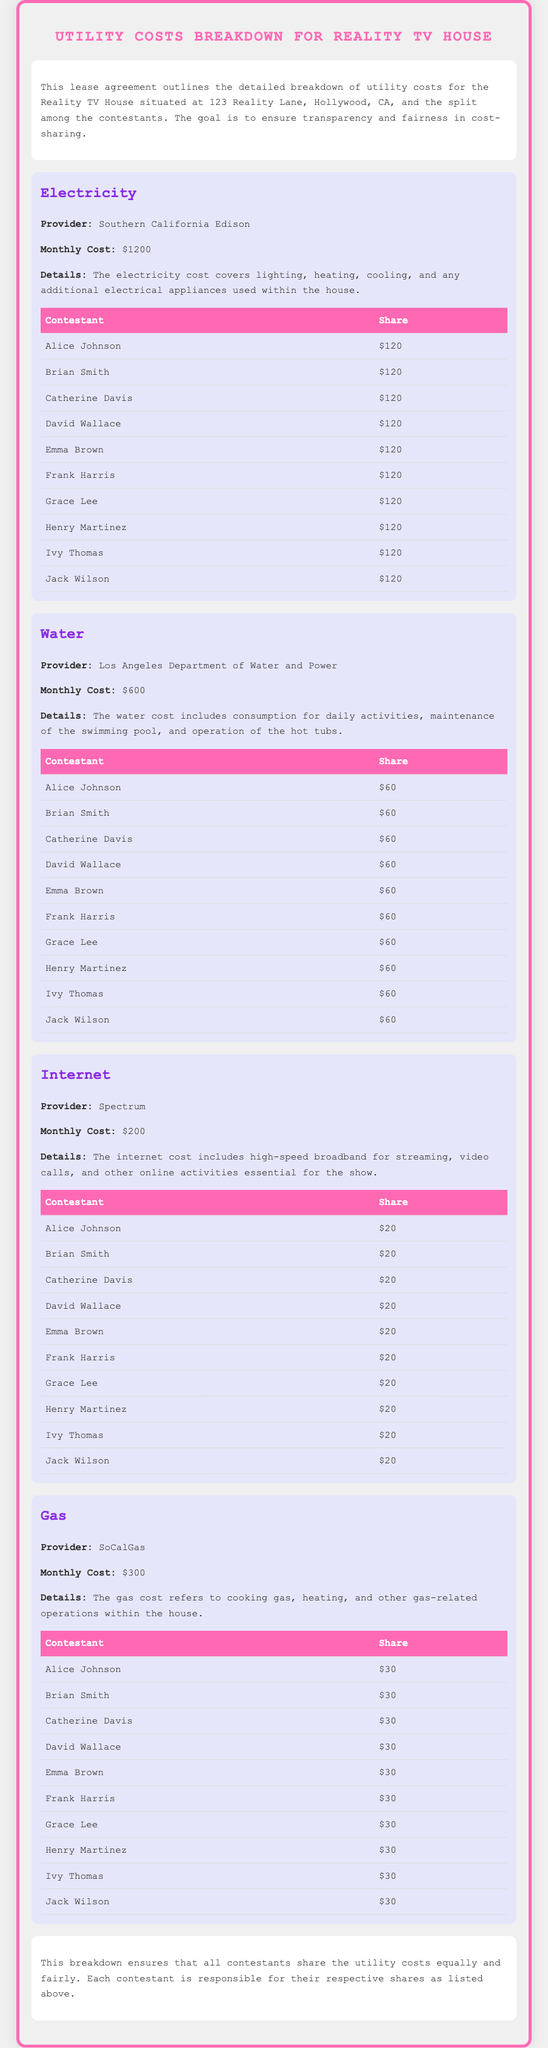What is the address of the Reality TV House? The address of the Reality TV House is specified in the document.
Answer: 123 Reality Lane, Hollywood, CA What is the monthly electricity cost? The monthly electricity cost is stated explicitly in the document under the electricity section.
Answer: $1200 Who is responsible for the internet service? The internet service provider is listed in the document under the internet section.
Answer: Spectrum How much does each contestant pay for water? The individual payment for water is shown in the water section under the respective shares for each contestant.
Answer: $60 What is the total monthly cost for all utilities combined? The total monthly cost can be calculated by adding the costs of electricity, water, internet, and gas as listed in the document.
Answer: $2400 Which contestant has the highest share for utilities? All contestants share the utility costs equally, as highlighted in the breakdowns provided in the document.
Answer: None What is the provider for gas service? The document specifies the provider for gas service in the gas section.
Answer: SoCalGas How much is the total share for all contestants for internet? The total share for internet can be calculated by multiplying the cost per contestant by the number of contestants listed.
Answer: $200 What is included in the water cost details? The details provided in the water section mention specific aspects covered by the water cost.
Answer: Consumption for daily activities, maintenance of the swimming pool, and operation of the hot tubs 